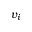<formula> <loc_0><loc_0><loc_500><loc_500>v _ { i }</formula> 